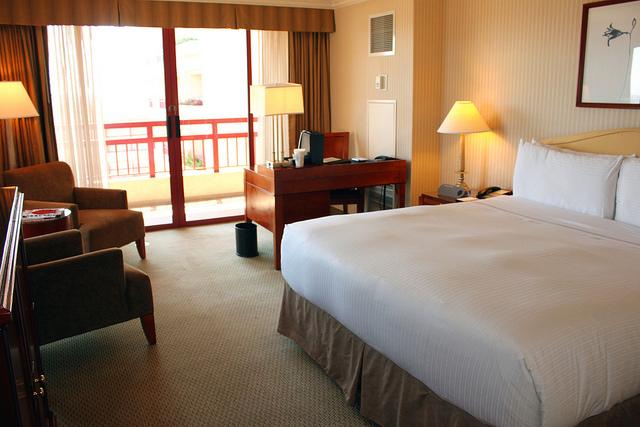What color is the floor?
Keep it brief. Beige. Is this a hotel?
Keep it brief. Yes. What size is the bed?
Give a very brief answer. King. 